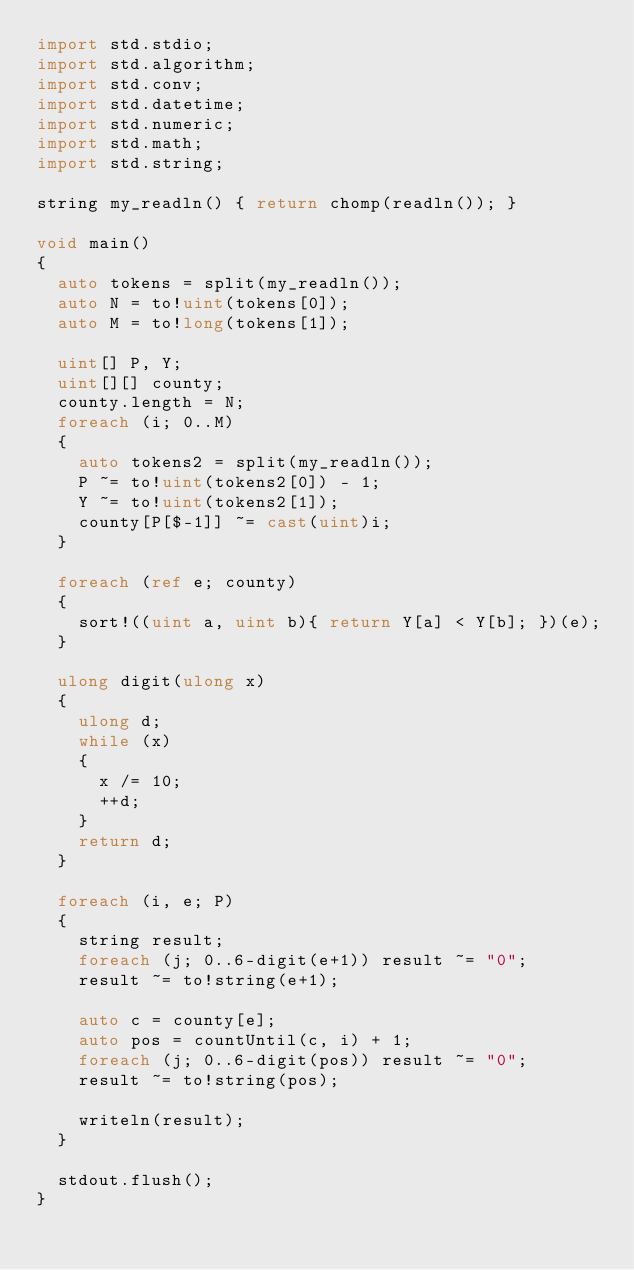<code> <loc_0><loc_0><loc_500><loc_500><_D_>import std.stdio;
import std.algorithm;
import std.conv;
import std.datetime;
import std.numeric;
import std.math;
import std.string;

string my_readln() { return chomp(readln()); }

void main()
{
	auto tokens = split(my_readln());
	auto N = to!uint(tokens[0]);
	auto M = to!long(tokens[1]);

	uint[] P, Y;
	uint[][] county;
	county.length = N;
	foreach (i; 0..M)
	{
		auto tokens2 = split(my_readln());
		P ~= to!uint(tokens2[0]) - 1;
		Y ~= to!uint(tokens2[1]);
		county[P[$-1]] ~= cast(uint)i;
	}

	foreach (ref e; county)
	{
		sort!((uint a, uint b){ return Y[a] < Y[b]; })(e);
	}

	ulong digit(ulong x)
	{
		ulong d;
		while (x)
		{
			x /= 10;
			++d;
		}
		return d;
	}

	foreach (i, e; P)
	{
		string result;
		foreach (j; 0..6-digit(e+1)) result ~= "0";
		result ~= to!string(e+1);

		auto c = county[e];
		auto pos = countUntil(c, i) + 1;
		foreach (j; 0..6-digit(pos)) result ~= "0";
		result ~= to!string(pos);

		writeln(result);
	}

	stdout.flush();
}</code> 